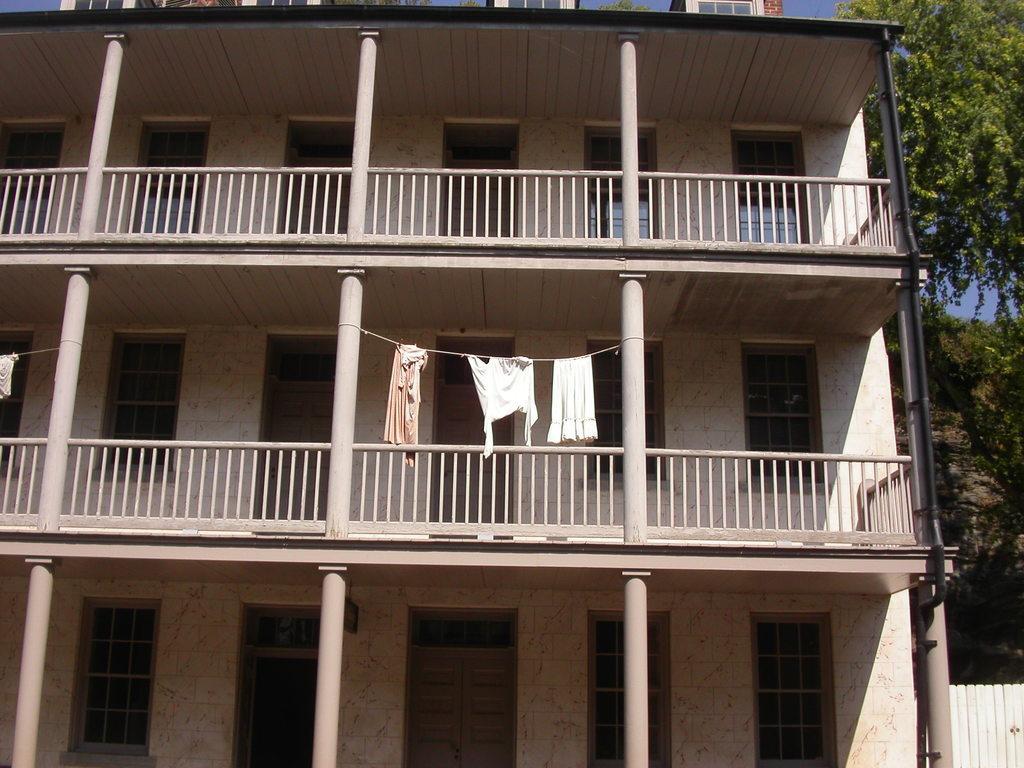Please provide a concise description of this image. In this picture there is a building in the center of the image and there is a boundary and trees on the right side of the image and there are clothes, which are hanged on the rope in the center of the image. 